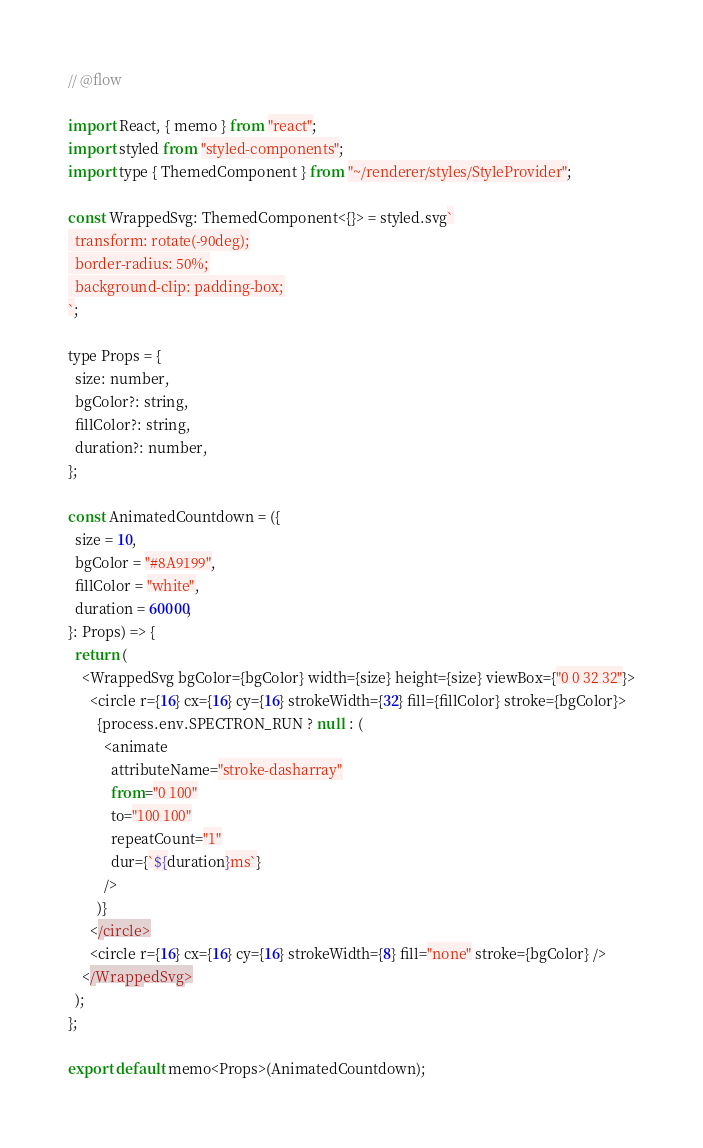<code> <loc_0><loc_0><loc_500><loc_500><_JavaScript_>// @flow

import React, { memo } from "react";
import styled from "styled-components";
import type { ThemedComponent } from "~/renderer/styles/StyleProvider";

const WrappedSvg: ThemedComponent<{}> = styled.svg`
  transform: rotate(-90deg);
  border-radius: 50%;
  background-clip: padding-box;
`;

type Props = {
  size: number,
  bgColor?: string,
  fillColor?: string,
  duration?: number,
};

const AnimatedCountdown = ({
  size = 10,
  bgColor = "#8A9199",
  fillColor = "white",
  duration = 60000,
}: Props) => {
  return (
    <WrappedSvg bgColor={bgColor} width={size} height={size} viewBox={"0 0 32 32"}>
      <circle r={16} cx={16} cy={16} strokeWidth={32} fill={fillColor} stroke={bgColor}>
        {process.env.SPECTRON_RUN ? null : (
          <animate
            attributeName="stroke-dasharray"
            from="0 100"
            to="100 100"
            repeatCount="1"
            dur={`${duration}ms`}
          />
        )}
      </circle>
      <circle r={16} cx={16} cy={16} strokeWidth={8} fill="none" stroke={bgColor} />
    </WrappedSvg>
  );
};

export default memo<Props>(AnimatedCountdown);
</code> 